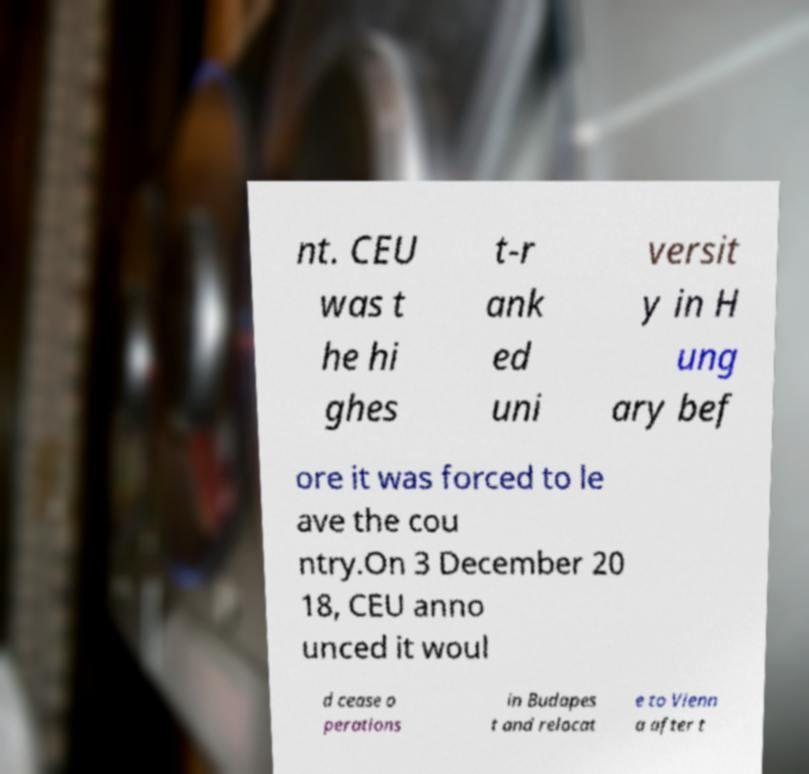What messages or text are displayed in this image? I need them in a readable, typed format. nt. CEU was t he hi ghes t-r ank ed uni versit y in H ung ary bef ore it was forced to le ave the cou ntry.On 3 December 20 18, CEU anno unced it woul d cease o perations in Budapes t and relocat e to Vienn a after t 